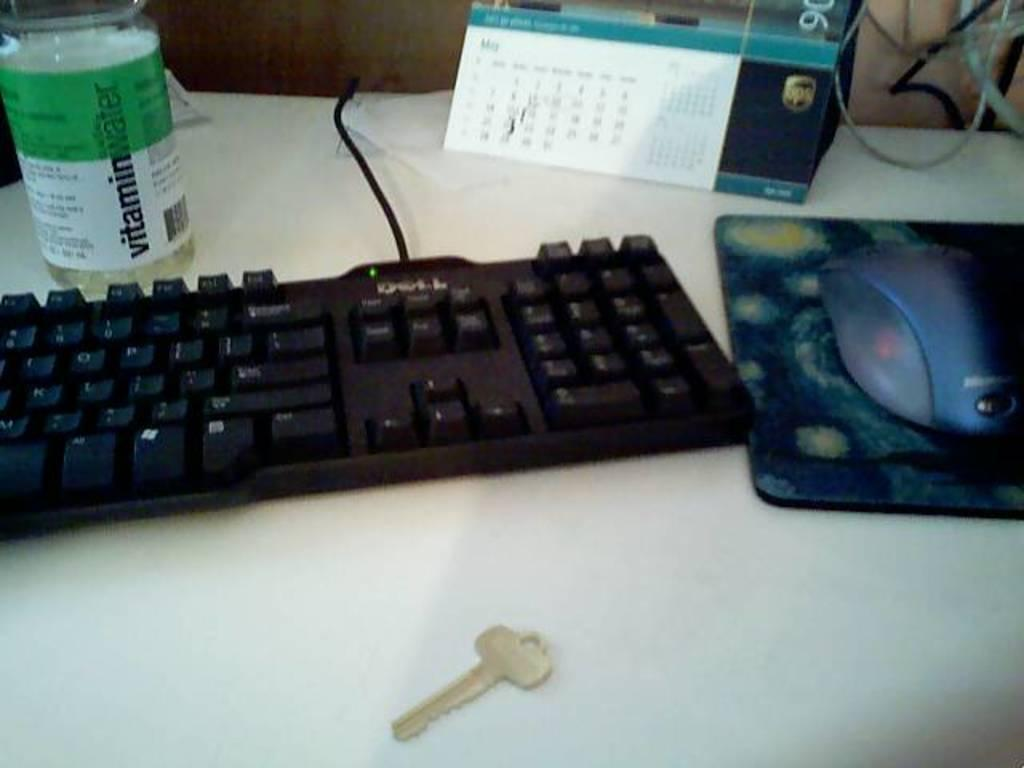Provide a one-sentence caption for the provided image. A key, a keyboard, a mouse, a calendar, and a bottle of vitamin water are on a desk. 